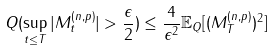<formula> <loc_0><loc_0><loc_500><loc_500>Q ( \sup _ { t \leq T } | M ^ { ( n , p ) } _ { t } | > \frac { \epsilon } { 2 } ) \leq \frac { 4 } { \epsilon ^ { 2 } } \mathbb { E } _ { Q } [ ( M ^ { ( n , p ) } _ { T } ) ^ { 2 } ]</formula> 